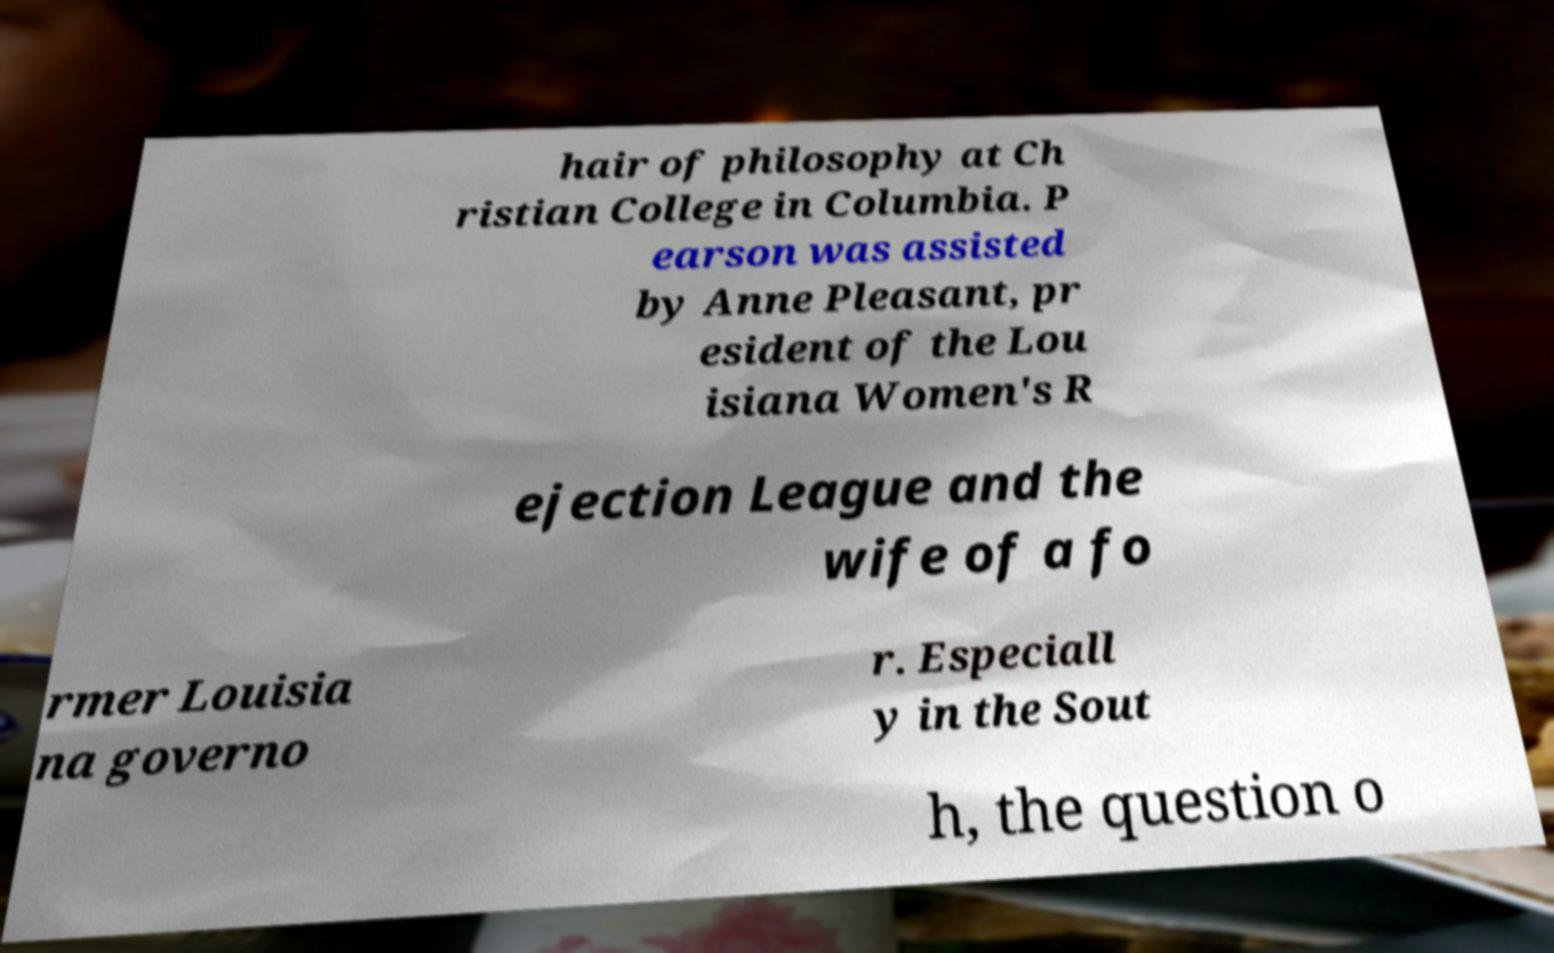Can you accurately transcribe the text from the provided image for me? hair of philosophy at Ch ristian College in Columbia. P earson was assisted by Anne Pleasant, pr esident of the Lou isiana Women's R ejection League and the wife of a fo rmer Louisia na governo r. Especiall y in the Sout h, the question o 